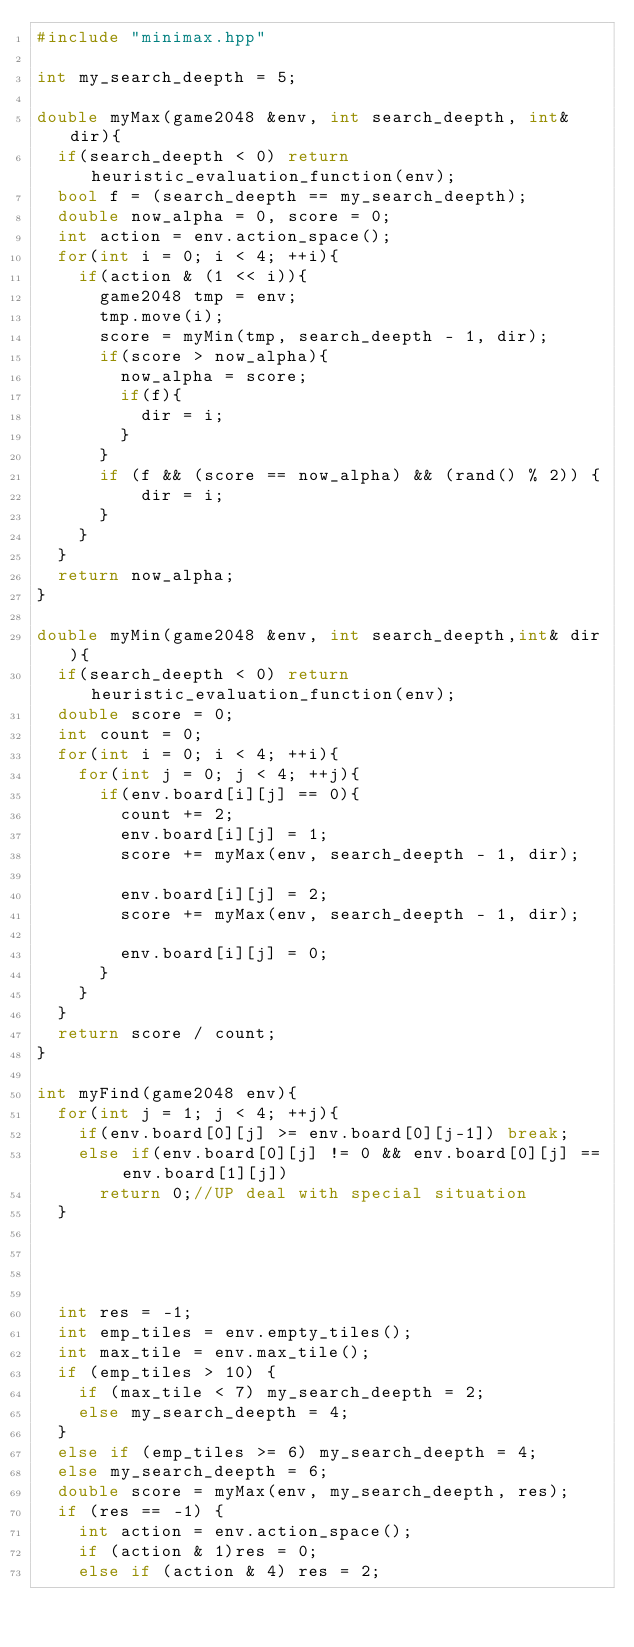Convert code to text. <code><loc_0><loc_0><loc_500><loc_500><_C++_>#include "minimax.hpp"

int my_search_deepth = 5;

double myMax(game2048 &env, int search_deepth, int& dir){
	if(search_deepth < 0) return heuristic_evaluation_function(env);
	bool f = (search_deepth == my_search_deepth);
	double now_alpha = 0, score = 0;
	int action = env.action_space();
	for(int i = 0; i < 4; ++i){
		if(action & (1 << i)){
			game2048 tmp = env;
			tmp.move(i);
			score = myMin(tmp, search_deepth - 1, dir);
			if(score > now_alpha){
				now_alpha = score;
				if(f){
					dir = i; 
				}
			}
			if (f && (score == now_alpha) && (rand() % 2)) {
					dir = i;
			}
		}
	}
	return now_alpha;
}

double myMin(game2048 &env, int search_deepth,int& dir){
	if(search_deepth < 0) return heuristic_evaluation_function(env);
	double score = 0;
	int count = 0;
	for(int i = 0; i < 4; ++i){
		for(int j = 0; j < 4; ++j){
			if(env.board[i][j] == 0){
				count += 2;
				env.board[i][j] = 1;
				score += myMax(env, search_deepth - 1, dir);
				
				env.board[i][j] = 2;
				score += myMax(env, search_deepth - 1, dir);
				
				env.board[i][j] = 0;
			}
		}
	}
	return score / count;
}

int myFind(game2048 env){
	for(int j = 1; j < 4; ++j){
		if(env.board[0][j] >= env.board[0][j-1]) break;
		else if(env.board[0][j] != 0 && env.board[0][j] == env.board[1][j])
			return 0;//UP deal with special situation
	}




	int res = -1;
	int emp_tiles = env.empty_tiles();
	int max_tile = env.max_tile();
	if (emp_tiles > 10) {
		if (max_tile < 7) my_search_deepth = 2;
		else my_search_deepth = 4;
	}
	else if (emp_tiles >= 6) my_search_deepth = 4;
	else my_search_deepth = 6;
	double score = myMax(env, my_search_deepth, res);
	if (res == -1) {
		int action = env.action_space();
		if (action & 1)res = 0;
		else if (action & 4) res = 2;</code> 